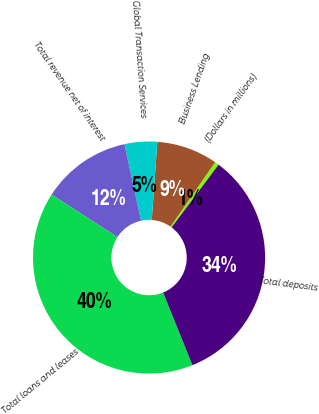<chart> <loc_0><loc_0><loc_500><loc_500><pie_chart><fcel>(Dollars in millions)<fcel>Business Lending<fcel>Global Transaction Services<fcel>Total revenue net of interest<fcel>Total loans and leases<fcel>Total deposits<nl><fcel>0.58%<fcel>8.51%<fcel>4.54%<fcel>12.47%<fcel>40.23%<fcel>33.68%<nl></chart> 